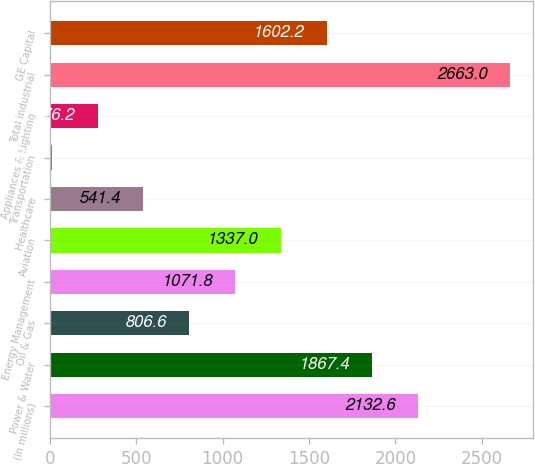<chart> <loc_0><loc_0><loc_500><loc_500><bar_chart><fcel>(In millions)<fcel>Power & Water<fcel>Oil & Gas<fcel>Energy Management<fcel>Aviation<fcel>Healthcare<fcel>Transportation<fcel>Appliances & Lighting<fcel>Total industrial<fcel>GE Capital<nl><fcel>2132.6<fcel>1867.4<fcel>806.6<fcel>1071.8<fcel>1337<fcel>541.4<fcel>11<fcel>276.2<fcel>2663<fcel>1602.2<nl></chart> 